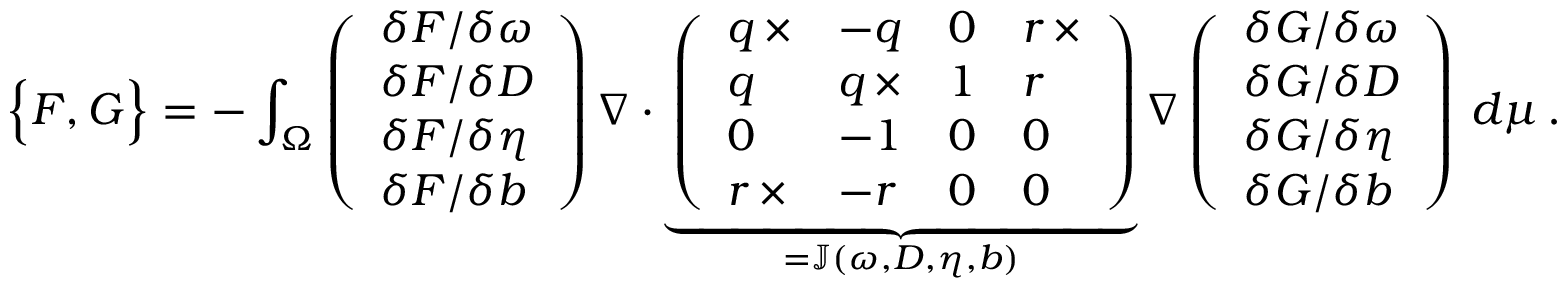<formula> <loc_0><loc_0><loc_500><loc_500>\left \{ F , G \right \} = - \int _ { \Omega } \left ( \begin{array} { l } { \delta F / \delta \omega } \\ { \delta F / \delta D } \\ { \delta F / \delta \eta } \\ { \delta F / \delta b } \end{array} \right ) \nabla \cdot \underbrace { \left ( \begin{array} { l l l l } { q \, \times } & { - q } & { 0 } & { r \, \times } \\ { q } & { q \, \times } & { 1 } & { r } \\ { 0 } & { - 1 } & { 0 } & { 0 } \\ { r \, \times } & { - r } & { 0 } & { 0 } \end{array} \right ) } _ { = \mathbb { J } ( \omega , D , \eta , b ) } \nabla \left ( \begin{array} { l } { \delta G / \delta \omega } \\ { \delta G / \delta D } \\ { \delta G / \delta \eta } \\ { \delta G / \delta b } \end{array} \right ) \, d \mu \, .</formula> 